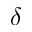<formula> <loc_0><loc_0><loc_500><loc_500>\delta</formula> 